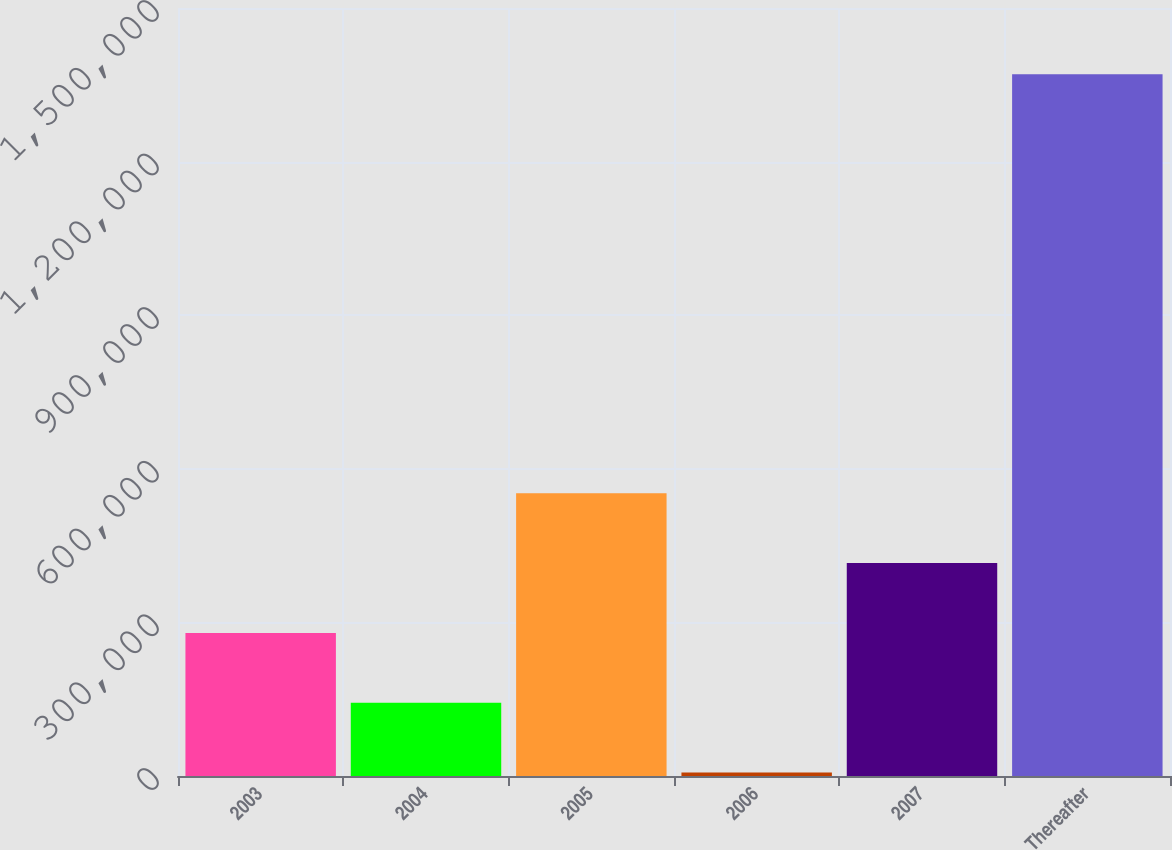Convert chart. <chart><loc_0><loc_0><loc_500><loc_500><bar_chart><fcel>2003<fcel>2004<fcel>2005<fcel>2006<fcel>2007<fcel>Thereafter<nl><fcel>279467<fcel>143059<fcel>552284<fcel>6651<fcel>415876<fcel>1.37073e+06<nl></chart> 